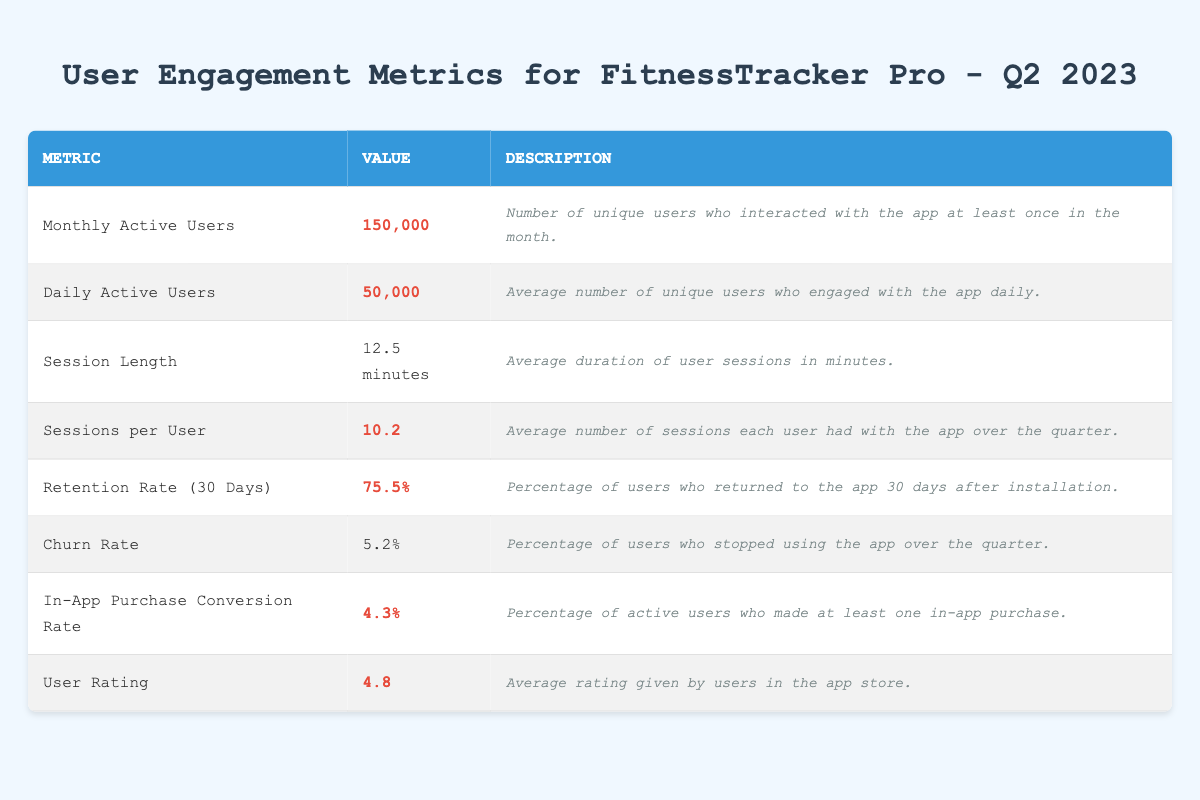What is the number of Monthly Active Users? The table shows the value listed under "Monthly Active Users" as 150,000.
Answer: 150,000 What is the average Daily Active Users count? The table indicates that the average Daily Active Users is 50,000.
Answer: 50,000 What is the average Session Length in minutes? The table provides the average Session Length as 12.5 minutes.
Answer: 12.5 minutes How many Sessions per User did users average in Q2 2023? According to the table, the average Sessions per User is 10.2.
Answer: 10.2 What is the Retention Rate after 30 days? The Retention Rate (30 Days) is stated as 75.5% in the table.
Answer: 75.5% Is the Churn Rate greater than 5%? The table shows the Churn Rate as 5.2%, which is greater than 5%.
Answer: Yes What percentage of users made an in-app purchase? The In-App Purchase Conversion Rate is listed as 4.3%.
Answer: 4.3% What is the average User Rating? The average User Rating is provided as 4.8 in the table.
Answer: 4.8 What is the total of the Monthly Active Users and Daily Active Users? The total is calculated by adding Monthly Active Users (150,000) and Daily Active Users (50,000), resulting in 150,000 + 50,000 = 200,000.
Answer: 200,000 What is the difference between Retention Rate and Churn Rate? The difference is calculated by subtracting the Churn Rate (5.2%) from the Retention Rate (75.5%), resulting in 75.5% - 5.2% = 70.3%.
Answer: 70.3% What is the average combined value of Sessions per User and In-App Purchase Conversion Rate? The average is found by adding Sessions per User (10.2) and In-App Purchase Conversion Rate (4.3), then dividing by 2: (10.2 + 4.3) / 2 = 7.25.
Answer: 7.25 